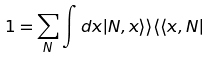<formula> <loc_0><loc_0><loc_500><loc_500>1 = \sum _ { N } \int d x | N , x \rangle \rangle \langle \langle x , N |</formula> 